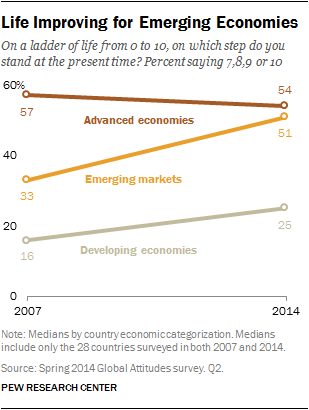List a handful of essential elements in this visual. The average of the 2007 data points is not greater than the average of the 2014 data points. A line with a value that always lies between the values of other two lines is orange. 